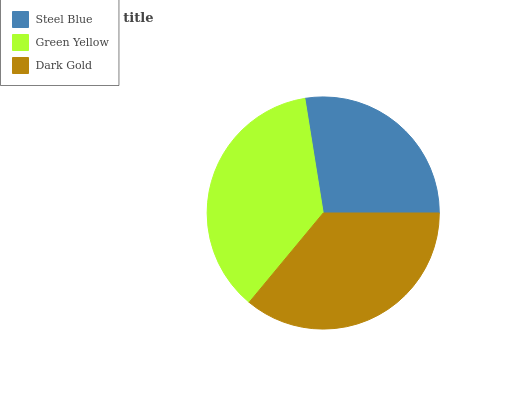Is Steel Blue the minimum?
Answer yes or no. Yes. Is Green Yellow the maximum?
Answer yes or no. Yes. Is Dark Gold the minimum?
Answer yes or no. No. Is Dark Gold the maximum?
Answer yes or no. No. Is Green Yellow greater than Dark Gold?
Answer yes or no. Yes. Is Dark Gold less than Green Yellow?
Answer yes or no. Yes. Is Dark Gold greater than Green Yellow?
Answer yes or no. No. Is Green Yellow less than Dark Gold?
Answer yes or no. No. Is Dark Gold the high median?
Answer yes or no. Yes. Is Dark Gold the low median?
Answer yes or no. Yes. Is Green Yellow the high median?
Answer yes or no. No. Is Green Yellow the low median?
Answer yes or no. No. 